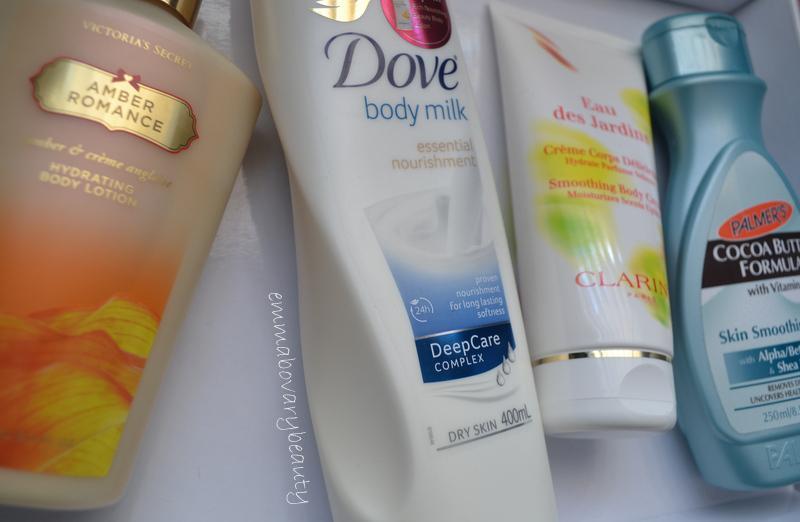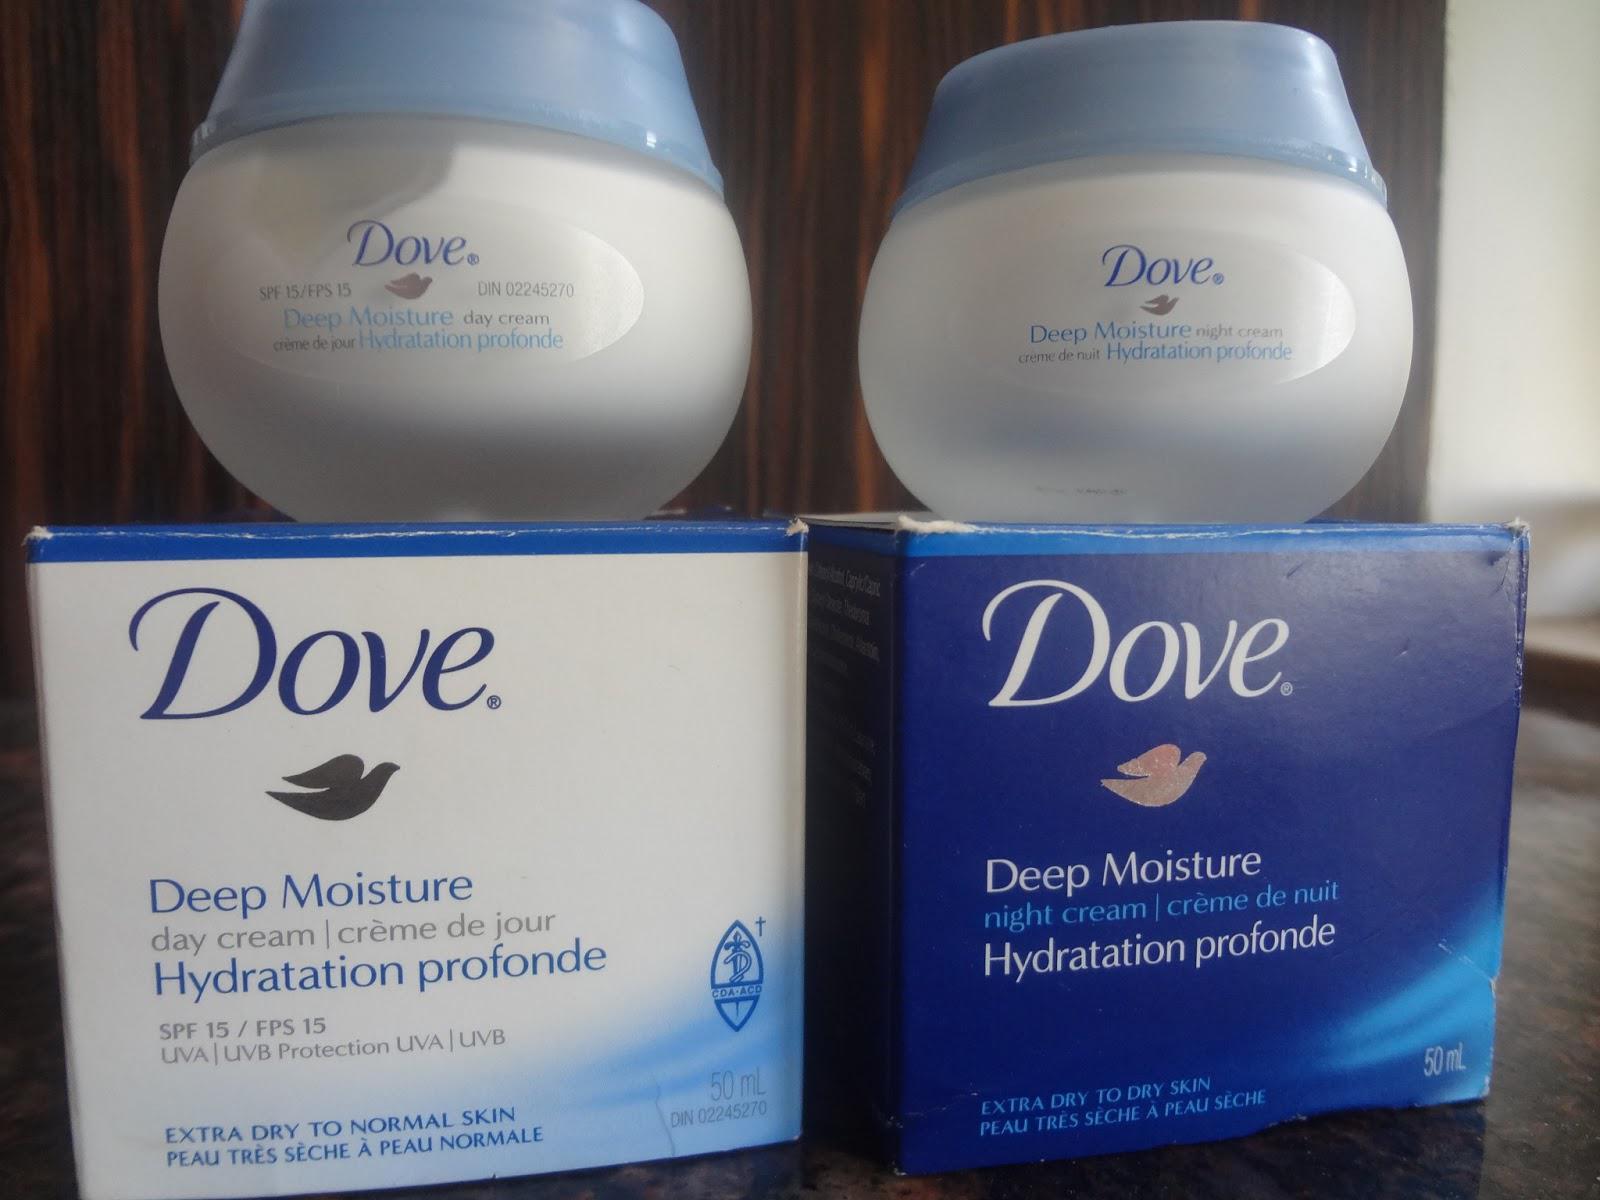The first image is the image on the left, the second image is the image on the right. Analyze the images presented: Is the assertion "There is at least one product shown with its corresponding box." valid? Answer yes or no. Yes. The first image is the image on the left, the second image is the image on the right. Given the left and right images, does the statement "The left image shows two containers labeled, """"Dove.""""" hold true? Answer yes or no. No. 